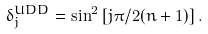Convert formula to latex. <formula><loc_0><loc_0><loc_500><loc_500>\delta _ { j } ^ { U D D } = \sin ^ { 2 } \left [ j \pi / 2 ( n + 1 ) \right ] .</formula> 